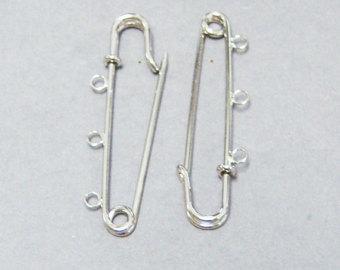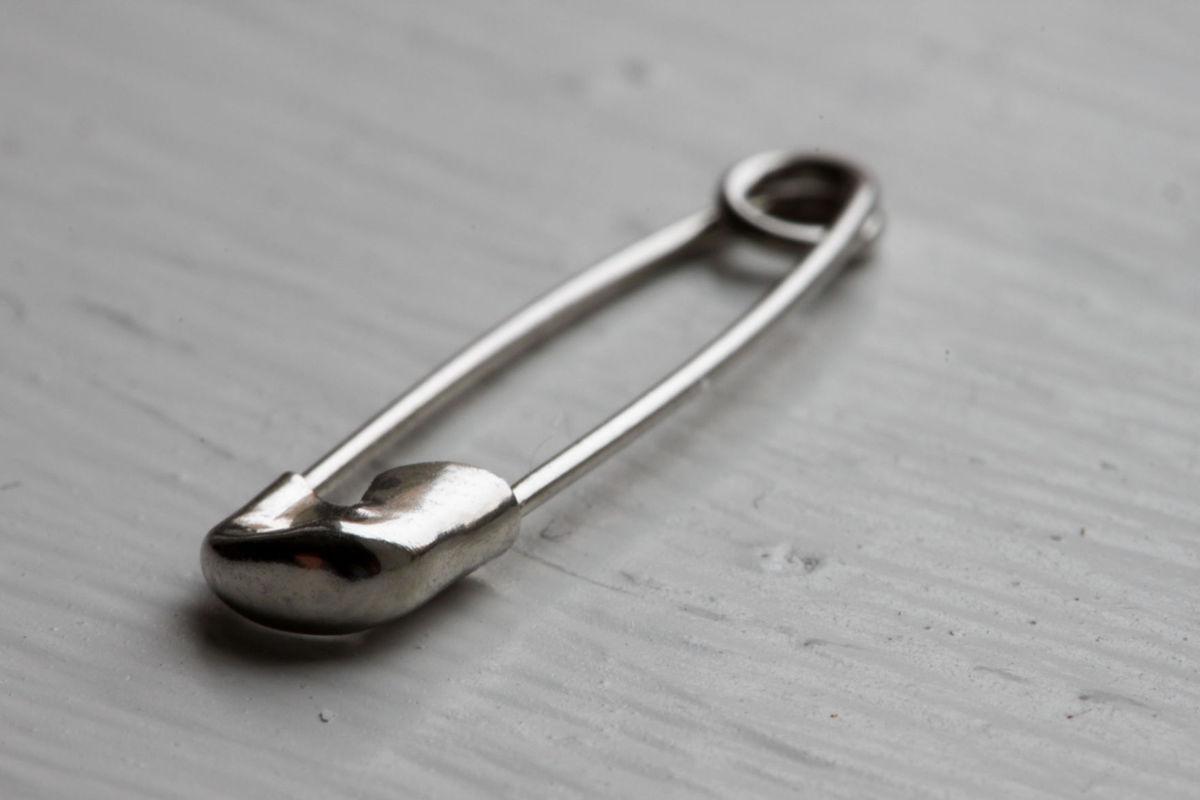The first image is the image on the left, the second image is the image on the right. Considering the images on both sides, is "One image contains exactly two safety pins." valid? Answer yes or no. Yes. 